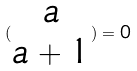Convert formula to latex. <formula><loc_0><loc_0><loc_500><loc_500>( \begin{matrix} a \\ a + 1 \end{matrix} ) = 0</formula> 